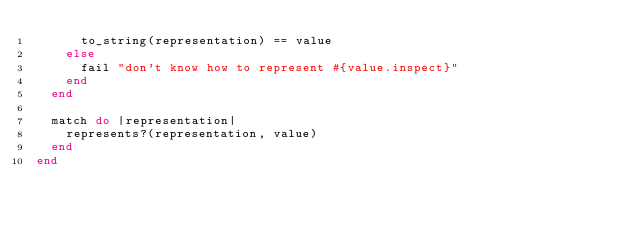Convert code to text. <code><loc_0><loc_0><loc_500><loc_500><_Ruby_>      to_string(representation) == value
    else
      fail "don't know how to represent #{value.inspect}"
    end
  end

  match do |representation|
    represents?(representation, value)
  end
end
</code> 